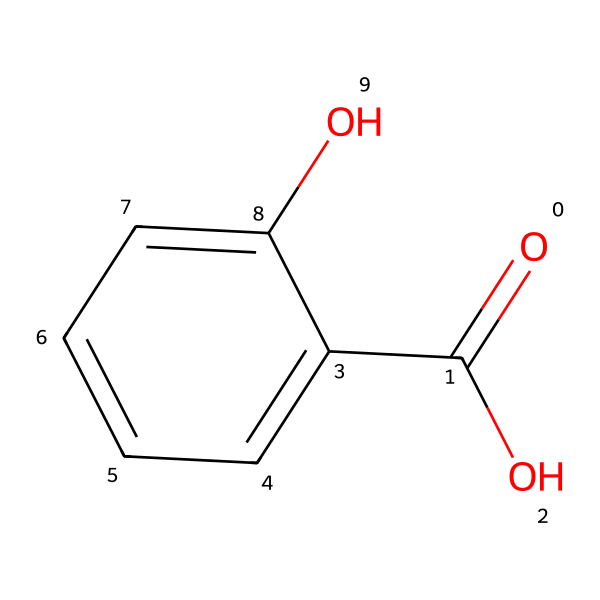What is the molecular formula of salicylic acid? To find the molecular formula, count the types and numbers of each atom in the SMILES notation. In the structure O=C(O)c1ccccc1O, there are 7 carbon (C) atoms, 6 hydrogen (H) atoms, and 3 oxygen (O) atoms. Thus, the molecular formula is C7H6O3.
Answer: C7H6O3 How many aromatic rings are present in salicylic acid? The presence of a benzene ring can be identified in the chemical structure. The structure c1ccccc1 indicates an aromatic ring. Since there is only one aromatic ring in the entire structure, the answer is 1.
Answer: 1 What is the functional group present in salicylic acid? The structure contains a carboxylic acid functional group, which is indicated by the -COOH part of the molecule (O=C(O)). This group is responsible for the acidic properties of salicylic acid.
Answer: carboxylic acid What is the key characteristic of phenolic compounds as seen in salicylic acid? Phenolic compounds are characterized by the presence of a hydroxyl group (-OH) directly attached to an aromatic ring. In salicylic acid, this can be seen with the -OH group on the benzene ring, confirming its classification as a phenolic compound.
Answer: hydroxyl group Does salicylic acid have anti-inflammatory properties? Salicylic acid is known for its anti-inflammatory properties, which is a significant reason for its use in acne treatments and other dermatological products. This property is directly related to the presence of the carboxylic acid group and the overall structure.
Answer: yes What is the maximum number of hydrogen atoms connected to salicylic acid? To determine the maximum number of hydrogen atoms, analyze the structure, noting that each carbon typically bonds to four total entities. In this case, the presence of oxygen atoms limits hydrogen attachment, yielding a structure that contains 6 hydrogen atoms.
Answer: 6 